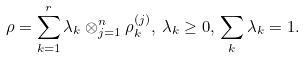<formula> <loc_0><loc_0><loc_500><loc_500>\rho = \sum _ { k = 1 } ^ { r } \lambda _ { k } \otimes _ { j = 1 } ^ { n } \rho _ { k } ^ { ( j ) } , \, \lambda _ { k } \geq 0 , \, \sum _ { k } \lambda _ { k } = 1 .</formula> 